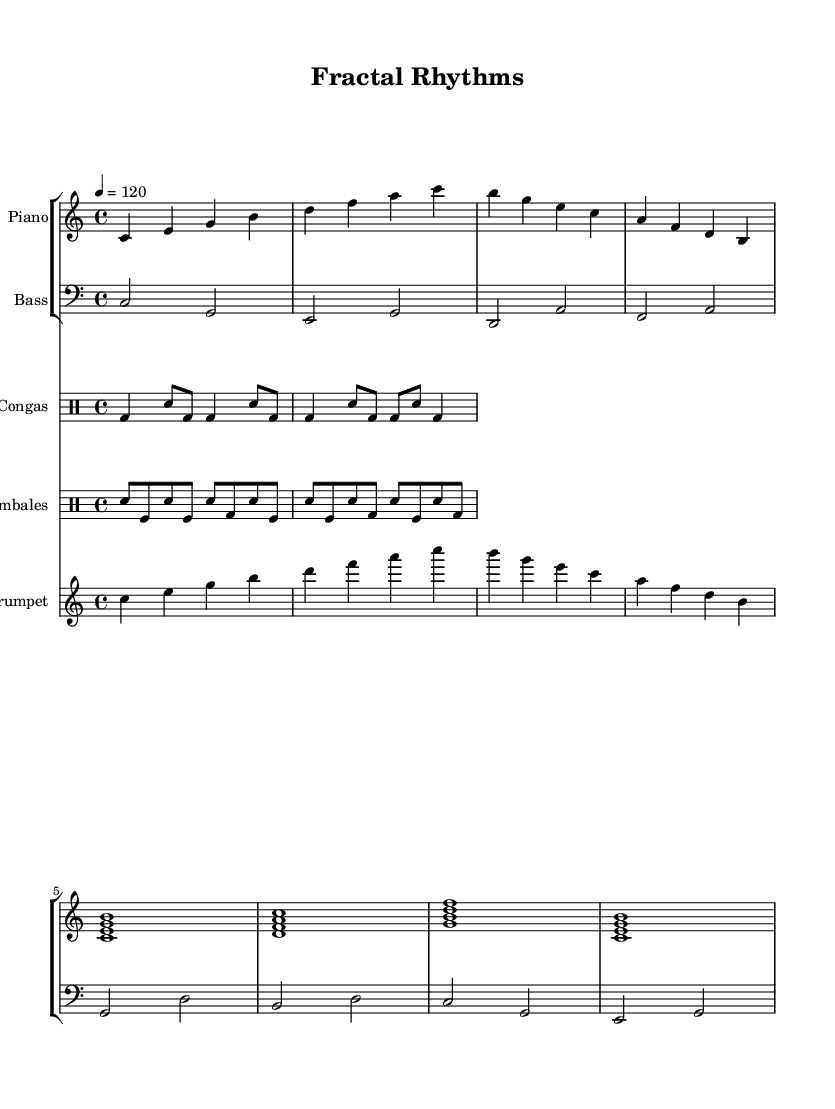what is the key signature of this music? The key signature is C major, which has no sharps or flats.
Answer: C major what is the time signature of this music? The time signature is indicated by the 4 over 4 symbol at the beginning, meaning there are four beats per measure.
Answer: 4/4 what is the tempo marking of this piece? The tempo is marked at a quarter note equals 120 beats per minute, indicating the speed of the music.
Answer: 120 how many measures are there in total in the piano part? By counting the groups of notes, there are a total of 8 measures in the piano part.
Answer: 8 how many different percussion instruments are used in this piece? The score includes two percussion instruments: congas and timbales, making for a total of two distinct percussion instruments.
Answer: 2 what rhythmic pattern is primarily used in the congas? The congas primarily feature a characteristic pattern that alternates between bass and snare hits, reflecting typical Afro-Cuban rhythms.
Answer: Alternating bass and snare which instrument plays the melody in this piece? The trumpet plays the melody, as inferred from its notation in the treble clef and its position above the other instruments in the score.
Answer: Trumpet 